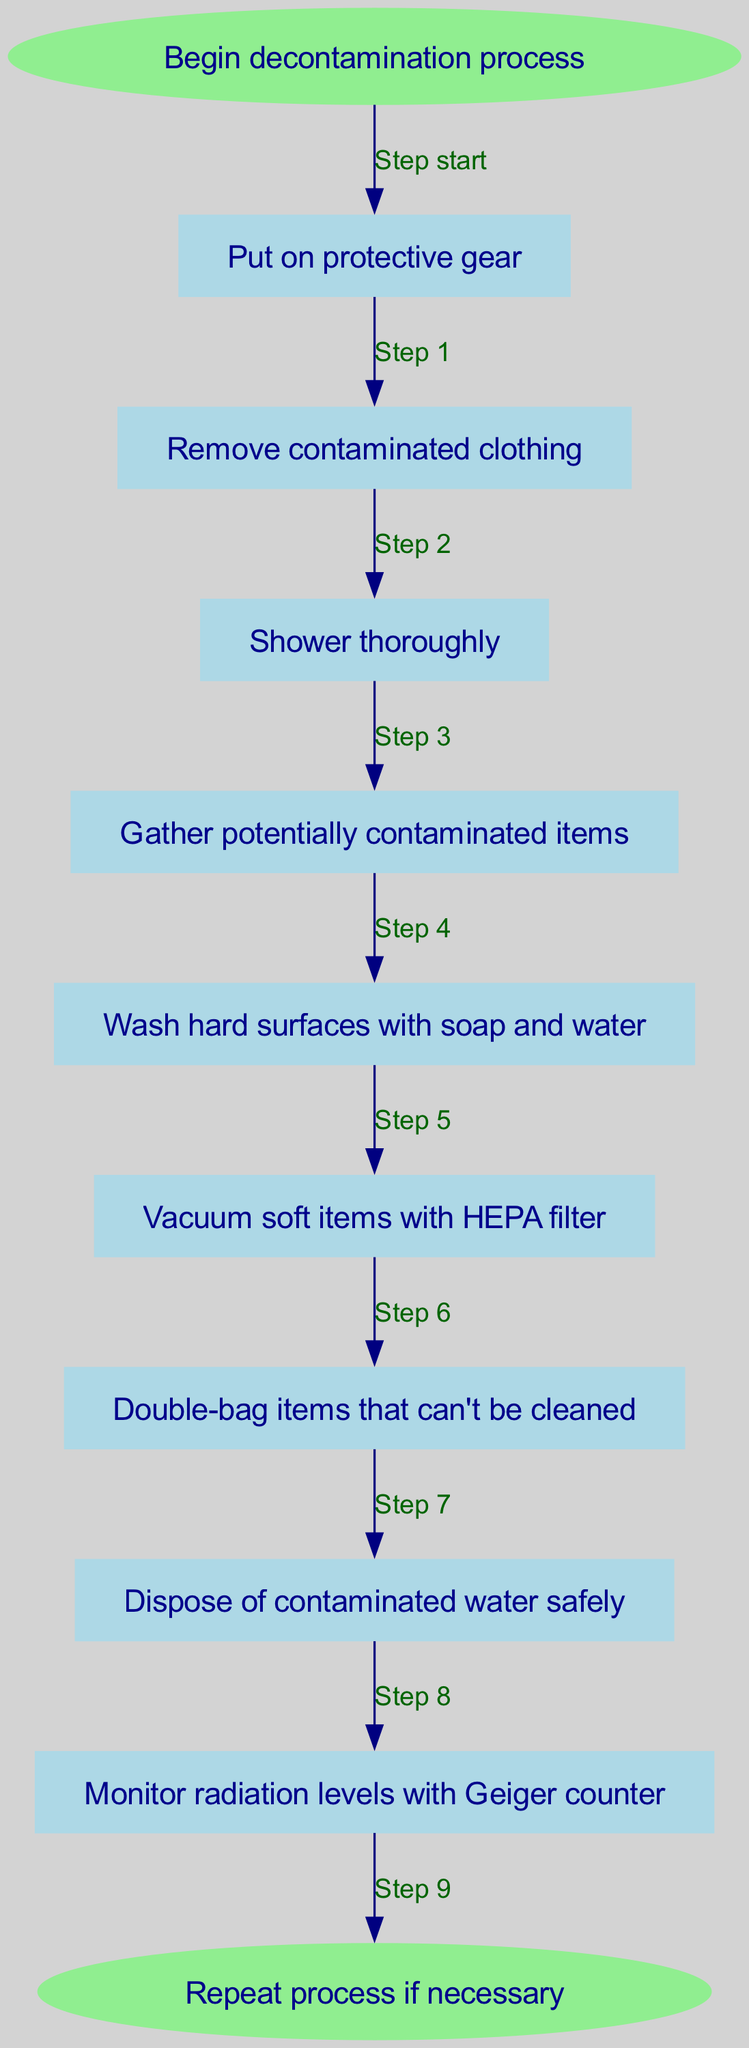What is the first step in the decontamination process? The diagram indicates that the first step, starting from the "Begin decontamination process" node, is to "Put on protective gear".
Answer: Put on protective gear How many steps are there in total? By counting the nodes listed in the diagram from start to end, there are a total of 10 steps involved in the process.
Answer: 10 What should be done after showering thoroughly? Following the "Shower thoroughly" step in the diagram, the next action required is to "Gather potentially contaminated items."
Answer: Gather potentially contaminated items Which step comes after washing hard surfaces? According to the flow of the diagram, "Vacuum soft items with HEPA filter" is the action that immediately follows "Wash hard surfaces with soap and water."
Answer: Vacuum soft items with HEPA filter What is the final step in the process? The flow chart concludes with the "Repeat process if necessary" node, indicating the end of the decontamination procedure.
Answer: Repeat process if necessary What should be done with items that can't be cleaned? The diagram specifies that contaminated items that cannot be cleaned should be "Double-bag items that can't be cleaned."
Answer: Double-bag items that can't be cleaned Which step requires monitoring radiation levels? The diagram details that "Monitor radiation levels with Geiger counter" is the step dedicated to checking radiation levels.
Answer: Monitor radiation levels with Geiger counter How do you safely dispose of contaminated water? The process indicates that the step of "Dispose of contaminated water safely" follows after double-bagging items that cannot be cleaned.
Answer: Dispose of contaminated water safely 